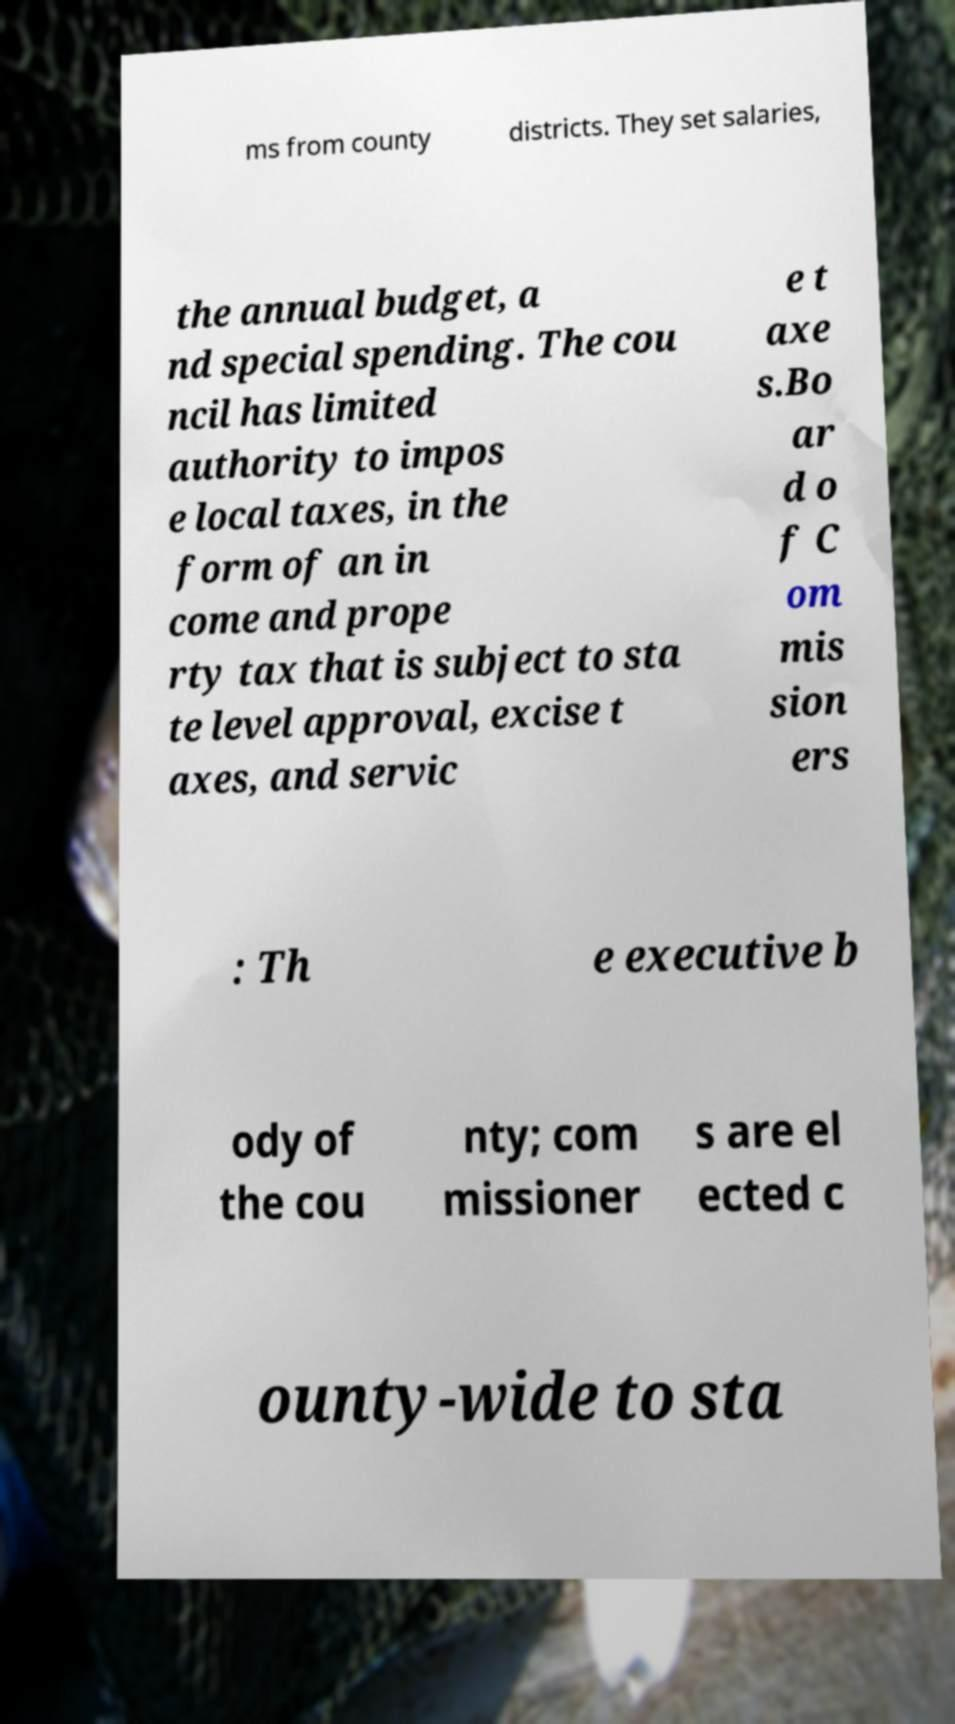Can you read and provide the text displayed in the image?This photo seems to have some interesting text. Can you extract and type it out for me? ms from county districts. They set salaries, the annual budget, a nd special spending. The cou ncil has limited authority to impos e local taxes, in the form of an in come and prope rty tax that is subject to sta te level approval, excise t axes, and servic e t axe s.Bo ar d o f C om mis sion ers : Th e executive b ody of the cou nty; com missioner s are el ected c ounty-wide to sta 